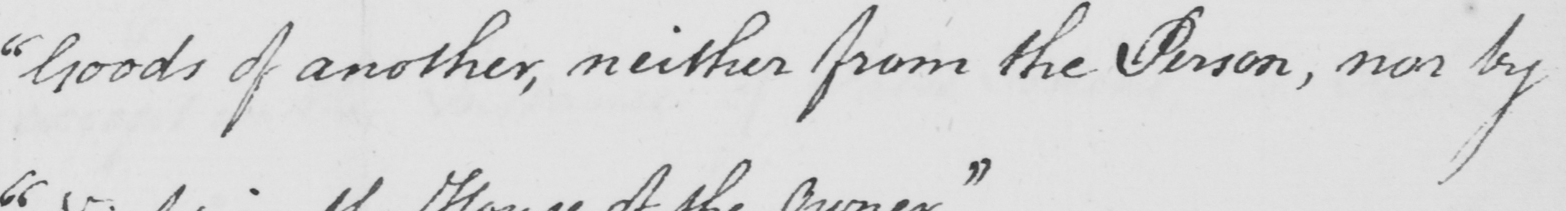Please provide the text content of this handwritten line. " Goods of another , neither from the Person , nor by 